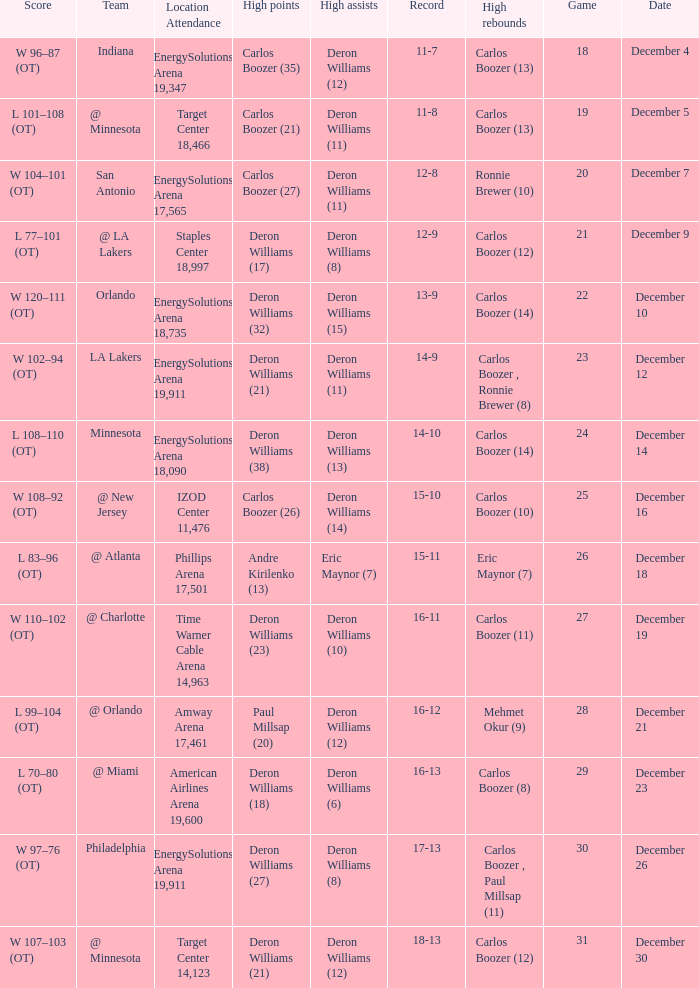When was the game in which Deron Williams (13) did the high assists played? December 14. 